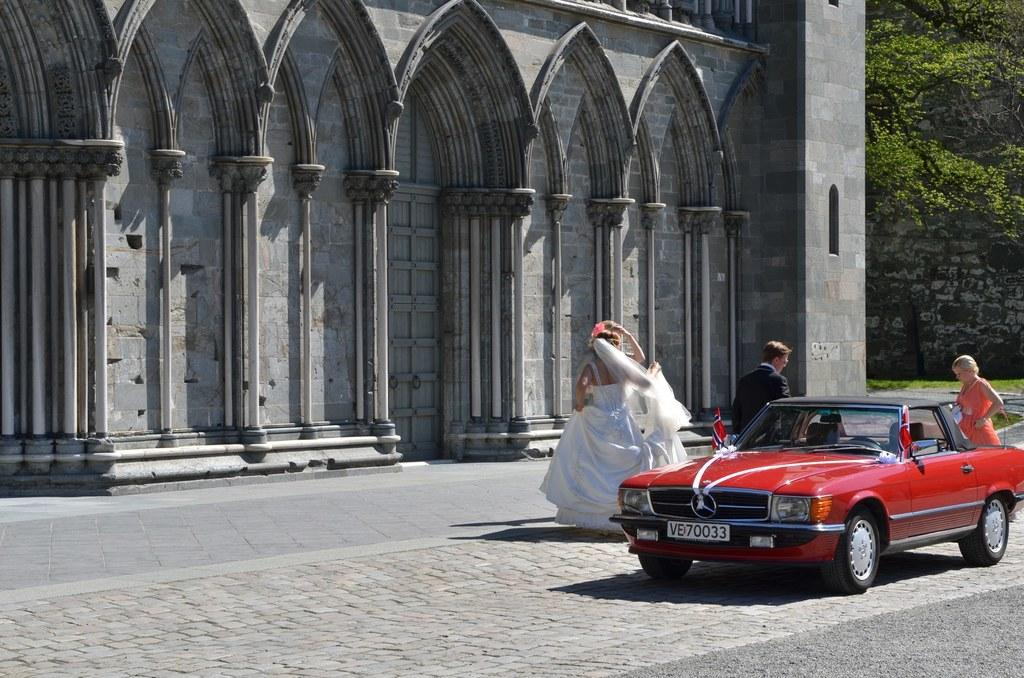What is the main structure visible in the image? There is a building in the image. What is located in front of the building? There are persons and a car in front of the building. What can be seen on the right side of the image? There is a wall, a tree, and grass on the right side of the image. What type of stocking is hanging from the tree in the image? There is no stocking hanging from the tree in the image. How many cherries can be seen on the persons in the image? There are no cherries visible on the persons in the image. 